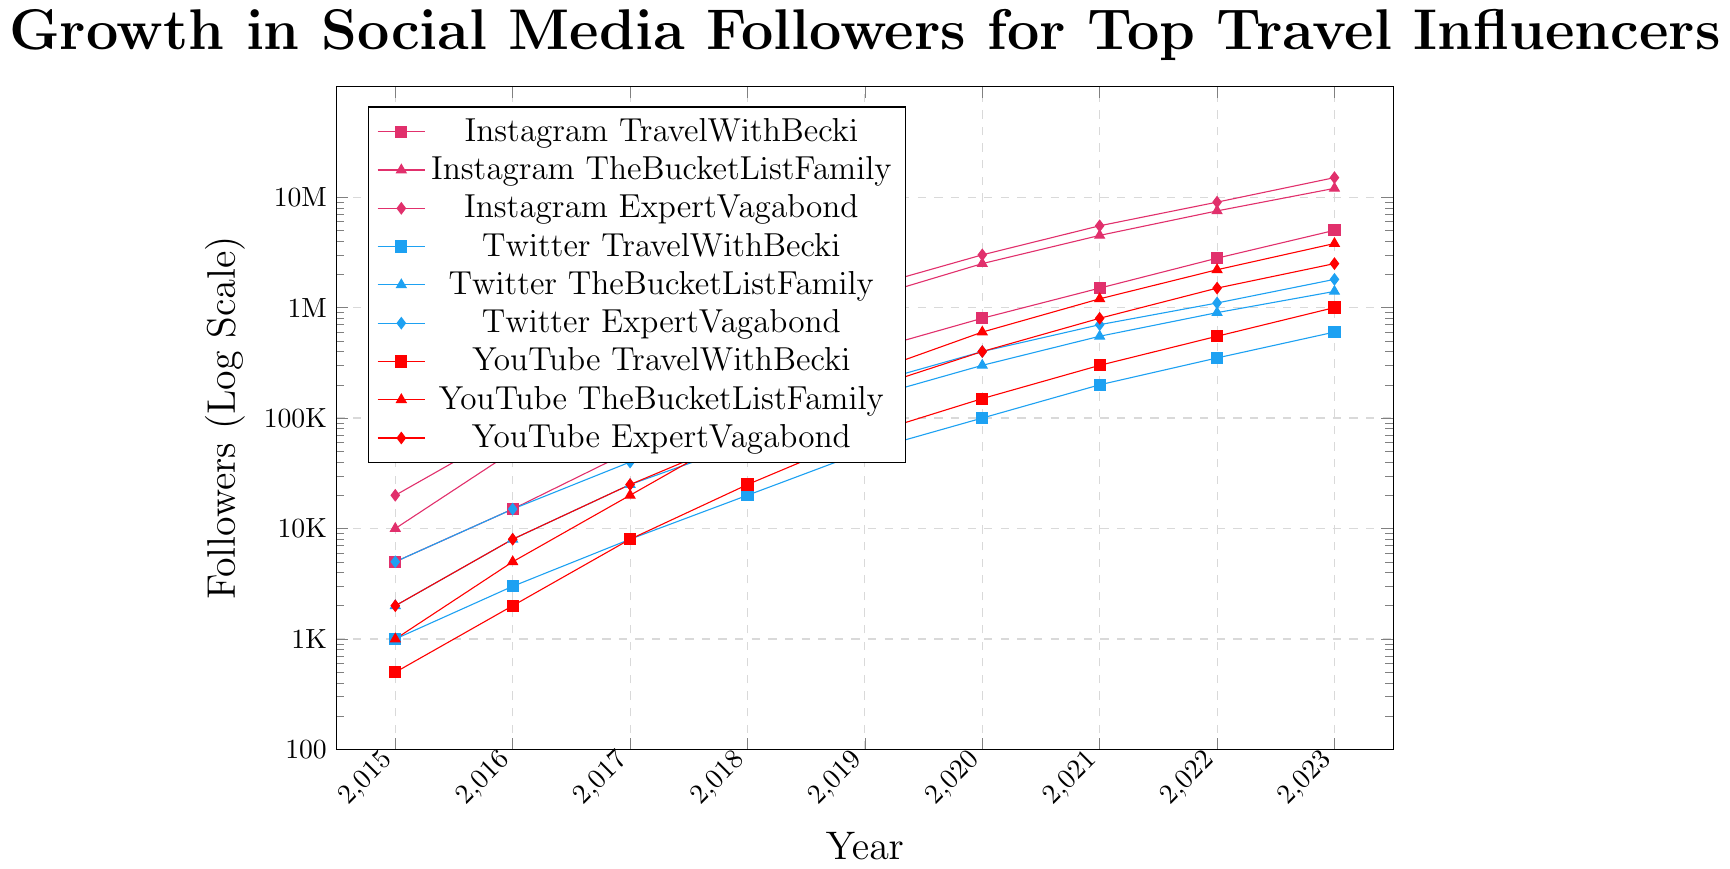What is the exponential growth rate of TheBucketListFamily on YouTube between 2017 and 2021? From 2017 to 2021, TheBucketListFamily's YouTube followers grew from approximately 20,000 to 1,200,000. The growth rate can be found by \( \text{Growth Rate} = \left(\frac{\text{Final Value}}{\text{Initial Value}}\right)^{1/\text{Years}} - 1 \). Plugging in the values, \( \left(\frac{1200000}{20000}\right)^{1/4} - 1 \), approximates to a rate of about 3.9
Answer: 3.9 Which platform shows the fastest growth for ExpertVagabond between 2015 and 2023? For ExpertVagabond, the growth on Instagram, Twitter, and YouTube can be compared. The approximate increases are:
Instagram: 20000 to 15000000
Twitter: 5000 to 1800000
YouTube: 2000 to 2500000
Instagram has the highest growth rate
Answer: Instagram In 2023, what is the difference in the number of followers between TravelWithBecki and ExpertVagabond on Twitter? In 2023, TravelWithBecki has 600,000 followers on Twitter while ExpertVagabond has 1,800,000 followers. The difference is \( 1800000 - 600000 = 1200000 \)
Answer: 1,200,000 Which influencer had the highest number of YouTube followers in 2020? In 2020, comparing YouTube followers of TravelWithBecki (150,000), TheBucketListFamily (600,000), and ExpertVagabond (400,000), TheBucketListFamily had the highest with 600,000 followers
Answer: TheBucketListFamily By how much did TheBucketListFamily’s Instagram followers grow between 2019 and 2022? In 2019, TheBucketListFamily had 1,200,000 followers on Instagram. In 2022, they had 7,500,000. The increase is \( 7500000 - 1200000 = 6300000 \)
Answer: 6,300,000 In which year did TravelWithBecki’s followers on YouTube first surpass 500,000? TravelWithBecki's YouTube followers surpassed 500,000 in 2022, as seen from the data, where followers were 550,000 in that year
Answer: 2022 